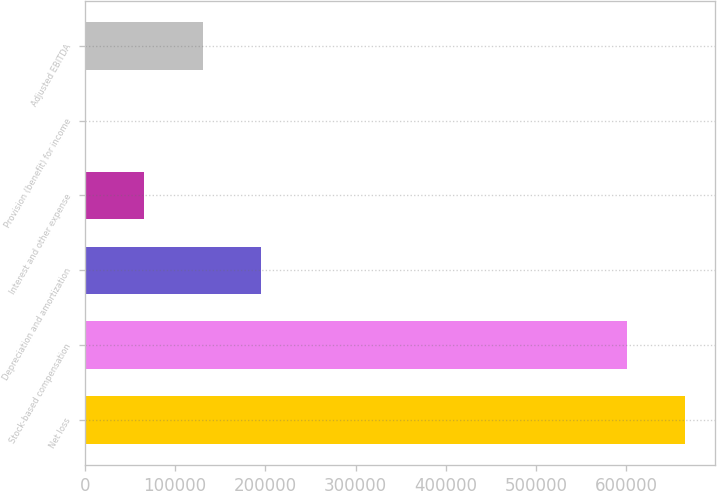Convert chart. <chart><loc_0><loc_0><loc_500><loc_500><bar_chart><fcel>Net loss<fcel>Stock-based compensation<fcel>Depreciation and amortization<fcel>Interest and other expense<fcel>Provision (benefit) for income<fcel>Adjusted EBITDA<nl><fcel>664717<fcel>600367<fcel>194873<fcel>66173<fcel>1823<fcel>130523<nl></chart> 